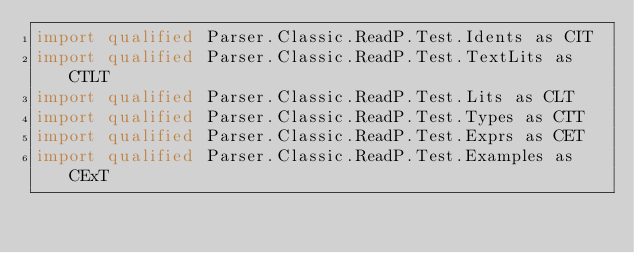<code> <loc_0><loc_0><loc_500><loc_500><_Haskell_>import qualified Parser.Classic.ReadP.Test.Idents as CIT
import qualified Parser.Classic.ReadP.Test.TextLits as CTLT
import qualified Parser.Classic.ReadP.Test.Lits as CLT
import qualified Parser.Classic.ReadP.Test.Types as CTT
import qualified Parser.Classic.ReadP.Test.Exprs as CET
import qualified Parser.Classic.ReadP.Test.Examples as CExT</code> 